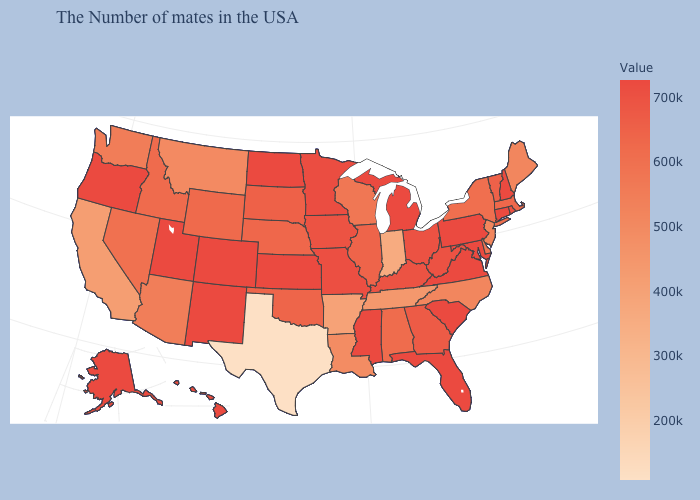Does Indiana have the lowest value in the MidWest?
Give a very brief answer. Yes. Does Hawaii have the lowest value in the USA?
Be succinct. No. Among the states that border Wisconsin , which have the lowest value?
Keep it brief. Illinois. Among the states that border Wyoming , does Nebraska have the lowest value?
Quick response, please. No. 